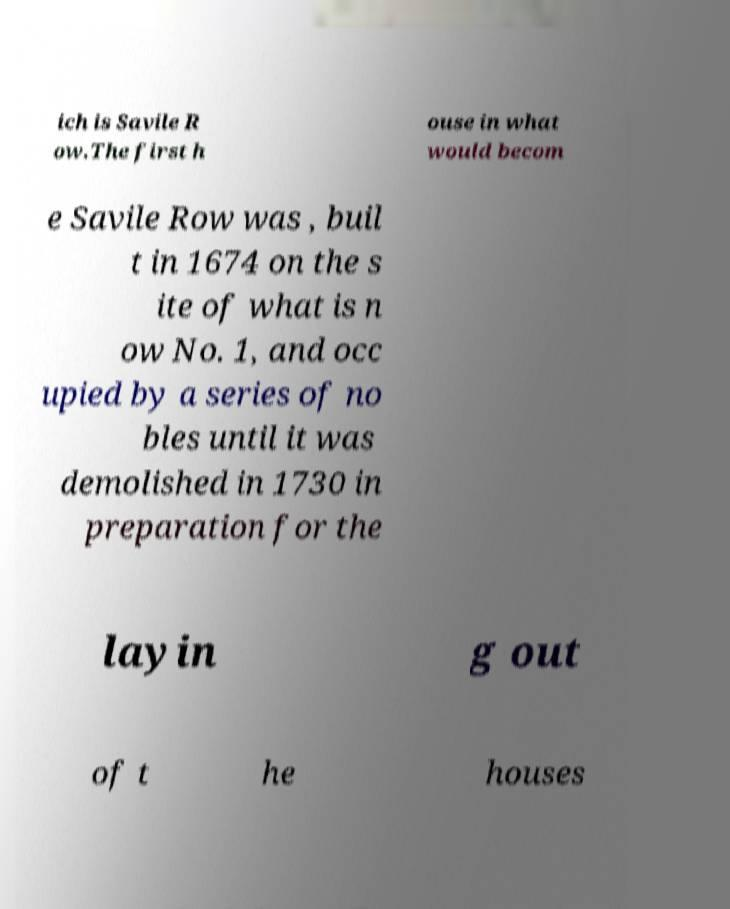Can you read and provide the text displayed in the image?This photo seems to have some interesting text. Can you extract and type it out for me? ich is Savile R ow.The first h ouse in what would becom e Savile Row was , buil t in 1674 on the s ite of what is n ow No. 1, and occ upied by a series of no bles until it was demolished in 1730 in preparation for the layin g out of t he houses 